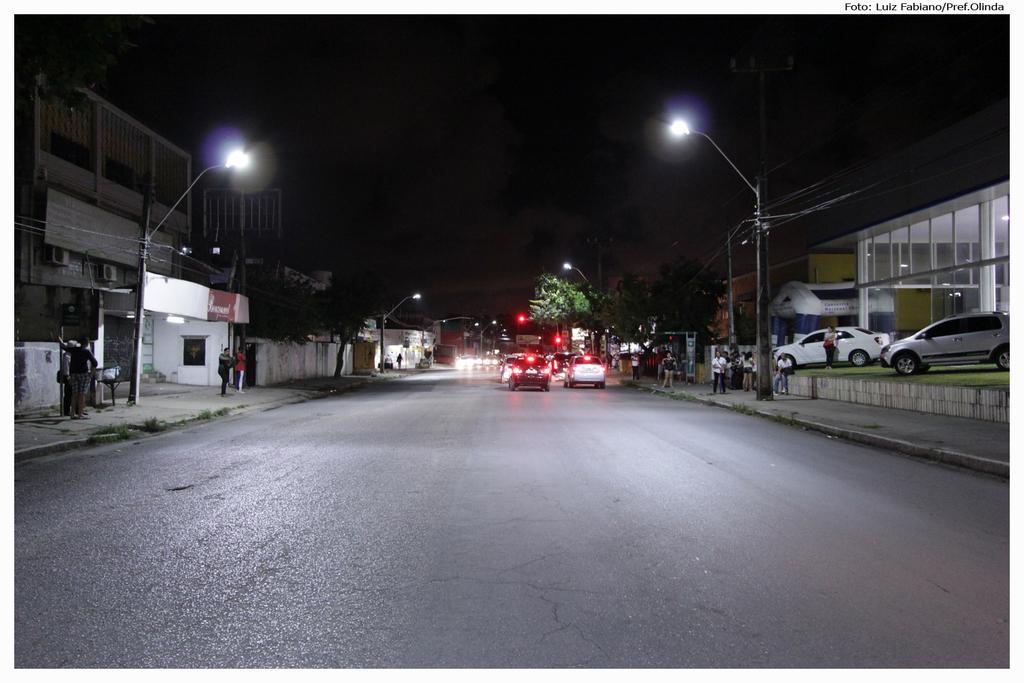How would you summarize this image in a sentence or two? In this picture we can observe a road. There are some cars on the road. On the right side we can observe two cars parked. On either sides of the road we can observe street light poles and buildings. In the background it is dark. 